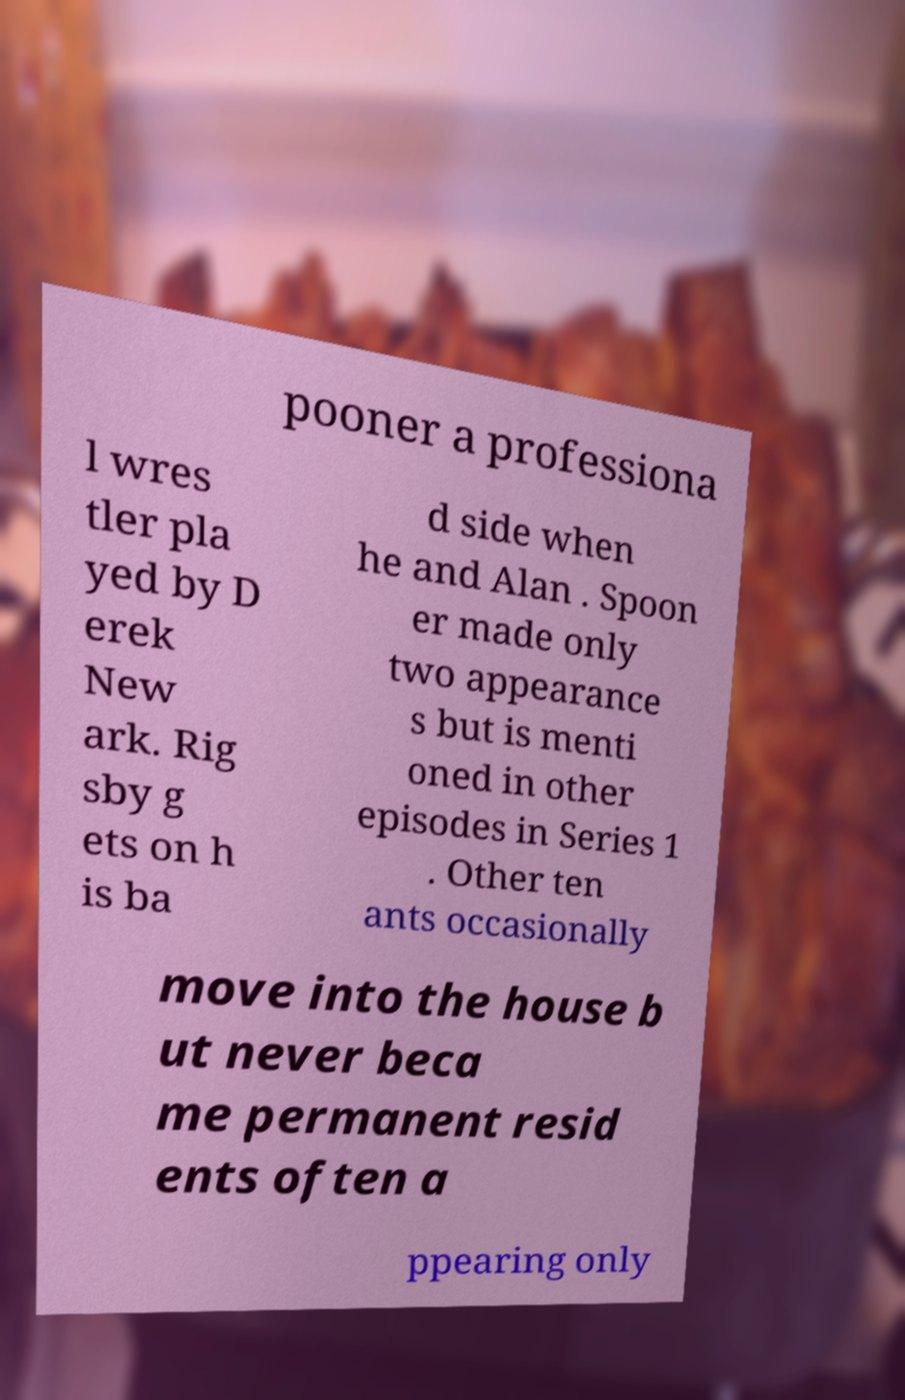For documentation purposes, I need the text within this image transcribed. Could you provide that? pooner a professiona l wres tler pla yed by D erek New ark. Rig sby g ets on h is ba d side when he and Alan . Spoon er made only two appearance s but is menti oned in other episodes in Series 1 . Other ten ants occasionally move into the house b ut never beca me permanent resid ents often a ppearing only 